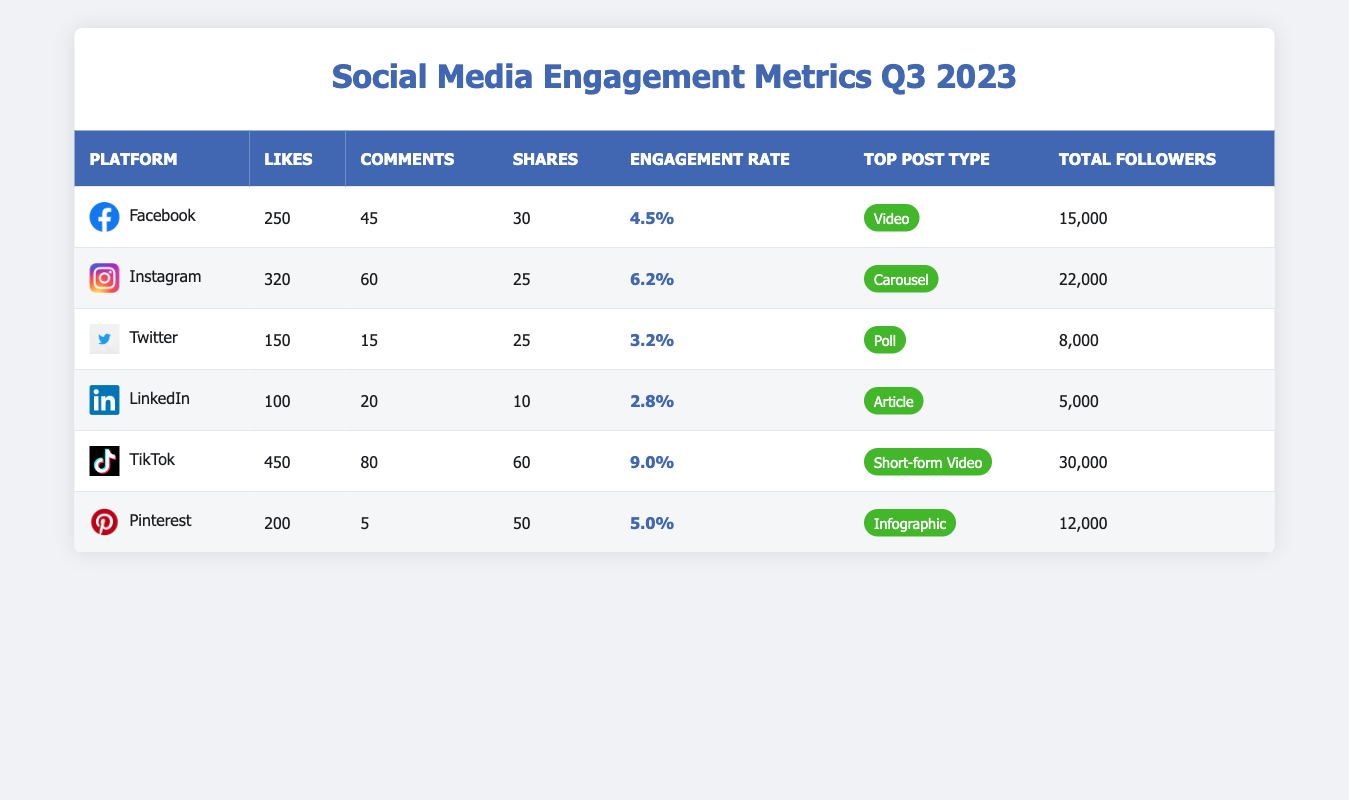What is the average engagement rate across all platforms? To find the average engagement rate, sum the engagement rates of each platform (4.5% + 6.2% + 3.2% + 2.8% + 9.0% + 5.0% = 30.7%) and divide by the number of platforms (6). Therefore, the average engagement rate is 30.7% / 6 ≈ 5.12%.
Answer: 5.12% Which platform has the highest likes per post? Looking at the likes per post column, Instagram has the highest value at 320 likes per post.
Answer: Instagram True or False: TikTok has more total followers than Facebook. TikTok has 30,000 followers, while Facebook has 15,000 followers. Since 30,000 is greater than 15,000, the statement is true.
Answer: True What is the difference in average engagement rate between TikTok and Twitter? TikTok's engagement rate is 9.0%, while Twitter's is 3.2%. The difference is 9.0% - 3.2% = 5.8%.
Answer: 5.8% What is the total number of likes per post across all platforms? Add up the likes from each platform: (250 + 320 + 150 + 100 + 450 + 200 = 1470). The total number of likes per post across all platforms is 1470.
Answer: 1470 Which platform's top post type is "Carousel"? The table shows that Instagram's top post type is "Carousel".
Answer: Instagram What is the average number of comments per post for the platforms listed? Calculate the average by summing the comments (45 + 60 + 15 + 20 + 80 + 5 = 225) and dividing by the number of platforms (6). The average is 225 / 6 ≈ 37.5 comments per post.
Answer: 37.5 On which platform are shares per post the lowest? Looking at the shares per post, LinkedIn has the lowest value at 10 shares per post.
Answer: LinkedIn What platform has an average engagement rate above 5%? The platforms with engagement rates above 5% are Instagram (6.2%) and TikTok (9.0%).
Answer: Instagram and TikTok If we combine the total followers of Facebook and Pinterest, how many total followers do they have? The total followers for Facebook are 15,000 and for Pinterest are 12,000. Adding them together gives 15,000 + 12,000 = 27,000 total followers.
Answer: 27,000 